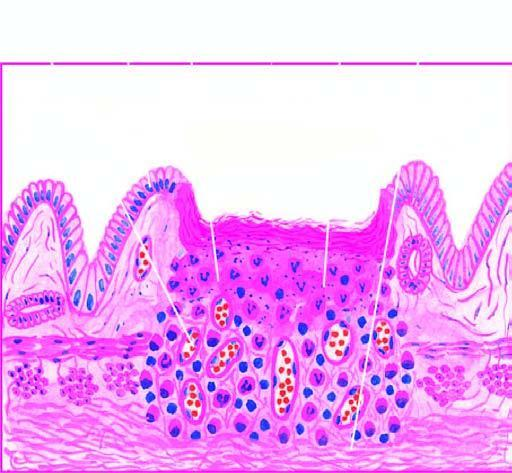what are histologic zones of the ulcer illustrated in?
Answer the question using a single word or phrase. Diagram 